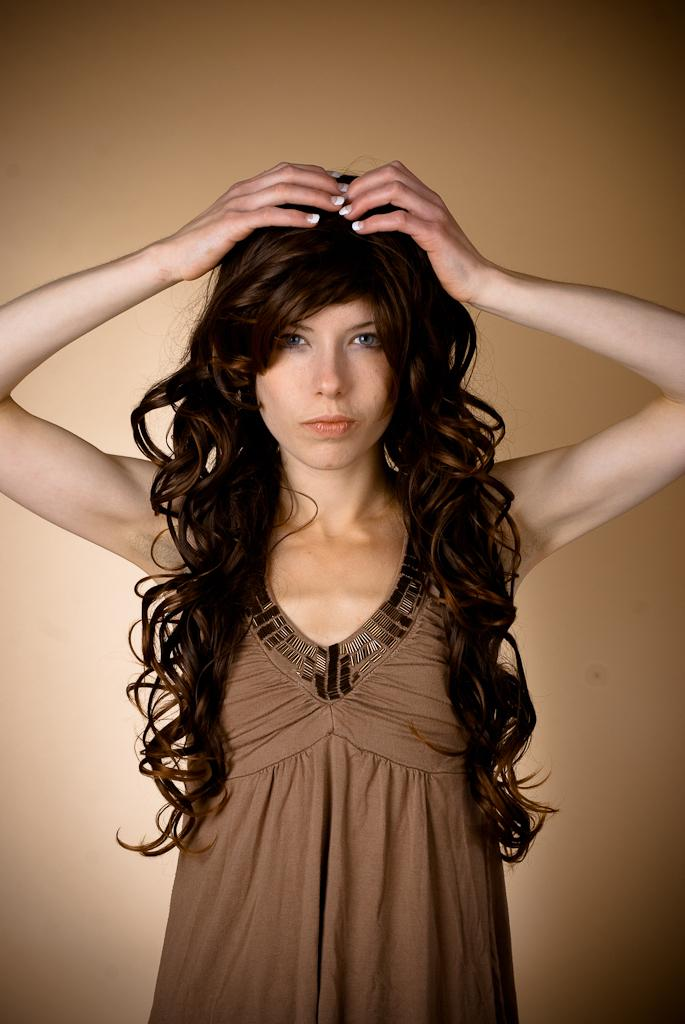Who is the main subject in the image? There is a woman in the image. What is the woman wearing? The woman is wearing a brown dress. Can you describe the woman's hair? The woman has long hair. What color is the background of the image? The background of the image is in brown color. What type of quartz can be seen in the woman's hand in the image? There is no quartz present in the image; the woman is not holding any quartz. How many buttons are visible on the woman's dress in the image? The woman's dress does not have any visible buttons in the image. 